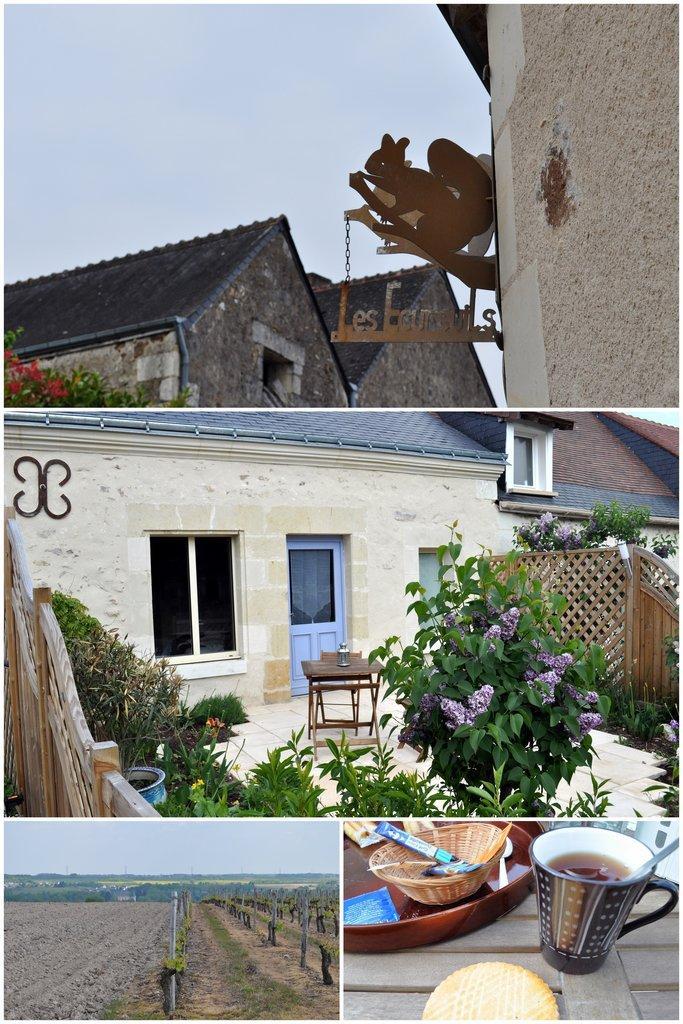Could you give a brief overview of what you see in this image? This is a collage picture. Here we can see houses, door, windows, plants, flowers, table, statue, board, ground, grass, cup with liquid, bowl, plate, food item, sky, and few objects. 